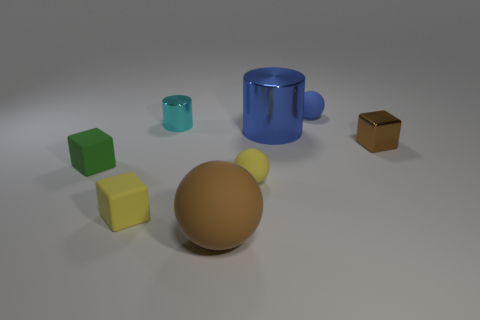Add 1 big purple shiny cylinders. How many objects exist? 9 Subtract all balls. How many objects are left? 5 Add 7 tiny brown objects. How many tiny brown objects are left? 8 Add 1 tiny shiny blocks. How many tiny shiny blocks exist? 2 Subtract 1 blue balls. How many objects are left? 7 Subtract all cyan shiny things. Subtract all tiny yellow matte things. How many objects are left? 5 